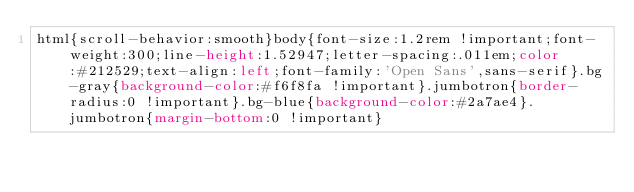Convert code to text. <code><loc_0><loc_0><loc_500><loc_500><_CSS_>html{scroll-behavior:smooth}body{font-size:1.2rem !important;font-weight:300;line-height:1.52947;letter-spacing:.011em;color:#212529;text-align:left;font-family:'Open Sans',sans-serif}.bg-gray{background-color:#f6f8fa !important}.jumbotron{border-radius:0 !important}.bg-blue{background-color:#2a7ae4}.jumbotron{margin-bottom:0 !important}</code> 